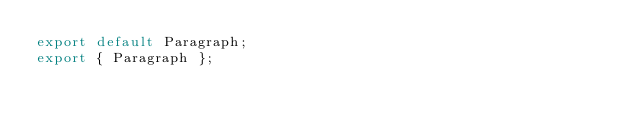<code> <loc_0><loc_0><loc_500><loc_500><_JavaScript_>export default Paragraph;
export { Paragraph };
</code> 